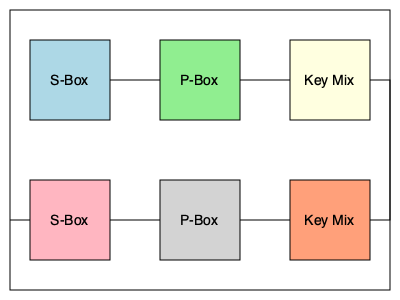In the visual representation of a block cipher above, which component is responsible for introducing non-linearity to the encryption process, and why is this crucial for the overall security of the algorithm? To answer this question, let's analyze the components of the block cipher shown in the diagram:

1. The diagram shows two rounds of a block cipher, each containing three main components:
   - S-Box (Substitution Box)
   - P-Box (Permutation Box)
   - Key Mix

2. Among these components, the S-Box is responsible for introducing non-linearity to the encryption process. Here's why:

   a) S-Box (Substitution Box):
      - Performs a non-linear transformation of the input data.
      - Typically implemented as a lookup table that maps input bits to output bits in a non-linear fashion.
      - Crucial for creating confusion in the cipher.

   b) P-Box (Permutation Box):
      - Rearranges the bits of the input without changing their values.
      - Provides diffusion but does not introduce non-linearity.

   c) Key Mix:
      - Usually performs an XOR operation between the data and the round key.
      - This operation is linear and does not introduce non-linearity.

3. The non-linearity introduced by the S-Box is crucial for the overall security of the algorithm because:
   - It makes the relationship between the plaintext, key, and ciphertext complex and difficult to analyze.
   - It helps resist linear and differential cryptanalysis attacks.
   - Without non-linearity, the entire cipher would be a series of linear operations, which could be easily broken using linear algebra techniques.

4. The combination of the non-linear S-Box with the linear operations (P-Box and Key Mix) creates a strong, secure cipher that is resistant to various cryptanalytic attacks.

In summary, the S-Box is the component responsible for introducing non-linearity, which is essential for the security and strength of the encryption algorithm.
Answer: S-Box (Substitution Box) 